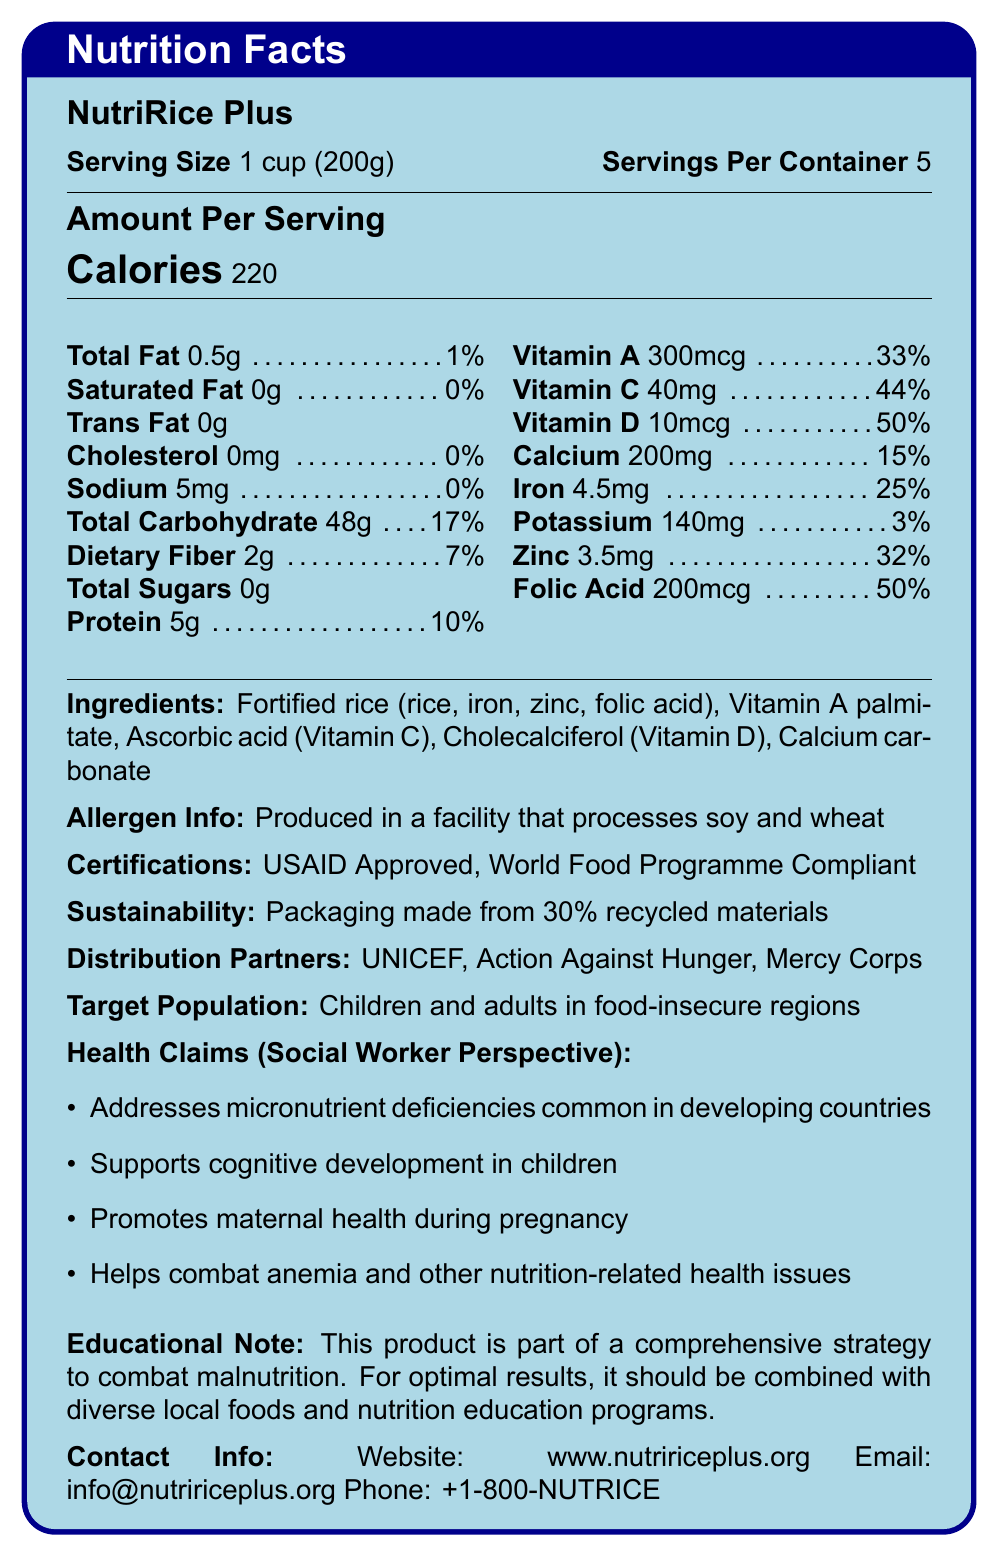what is the calorie content per serving? The document lists that each serving of NutriRice Plus contains 220 calories.
Answer: 220 calories how many servings are there in one container? The document states that there are 5 servings per container.
Answer: 5 servings what is the amount of dietary fiber per serving? The document states that each serving contains 2 grams of dietary fiber.
Answer: 2 grams which vitamin has the highest daily value percentage per serving? The document indicates that Vitamin D has a daily value percentage of 50%, which is the highest among the listed vitamins and minerals.
Answer: Vitamin D what certification does NutriRice Plus have? The document lists both “USAID Approved” and “World Food Programme Compliant” under Certifications.
Answer: USAID Approved and World Food Programme Compliant what is the total carbohydrate content per serving? The document lists the total carbohydrate content per serving as 48 grams.
Answer: 48 grams which organizations are listed as distribution partners? A. UNICEF B. Mercy Corps C. Action Against Hunger D. All of the above The document mentions UNICEF, Action Against Hunger, and Mercy Corps as distribution partners.
Answer: D what percentage of the daily value of calcium is provided in one serving? A. 10% B. 15% C. 20% D. 25% The document indicates that one serving of NutriRice Plus provides 15% of the daily value for calcium.
Answer: B does NutriRice Plus contain any trans fat? According to the document, the trans fat content in NutriRice Plus is 0g, which means it does not contain any trans fat.
Answer: No summarize the main idea of the document. The document outlines the nutritional content, certifications, and health claims associated with NutriRice Plus. It also provides information on its ingredients, allergen information, and distribution partners, highlighting its aim to combat malnutrition.
Answer: NutriRice Plus is a fortified rice product designed to address malnutrition in developing countries by providing essential vitamins and minerals. It is packaged sustainably, certified by major global organizations, and distributed by reputable partners, targeting children and adults in food-insecure regions. how much potassium is in one serving? The document states that one serving contains 140 milligrams of potassium.
Answer: 140 milligrams what are some health claims associated with NutriRice Plus from a social worker's perspective? The document lists several health claims from a social worker’s perspective, including addressing micronutrient deficiencies, supporting cognitive development, promoting maternal health, and combating anemia.
Answer: Addresses micronutrient deficiencies, supports cognitive development, promotes maternal health, helps combat anemia. does the document provide information about the environmental sustainability of the packaging? The document mentions that the packaging is made from 30% recycled materials, indicating a consideration for environmental sustainability.
Answer: Yes what are the exact amounts of Vitamin A and Vitamin C per serving? The document lists 300 mcg of Vitamin A and 40 mg of Vitamin C per serving.
Answer: Vitamin A: 300 mcg, Vitamin C: 40 mg what is the main ingredient in NutriRice Plus? The document lists fortified rice, including rice, iron, zinc, and folic acid, as the main ingredient.
Answer: Fortified rice (rice, iron, zinc, folic acid) what is the total fat content per serving and its percentage of daily value? A. 0.5g, 1% B. 0.5g, 5% C. 1g, 1% D. 1g, 5% The document indicates that the total fat content per serving is 0.5g, which corresponds to 1% of the daily value.
Answer: A who is the target population for NutriRice Plus? The document states that the target population for NutriRice Plus is children and adults in food-insecure regions.
Answer: Children and adults in food-insecure regions what is the role of folic acid in NutriRice Plus? The document mentions folic acid but does not provide specific information about its role in NutriRice Plus.
Answer: Cannot be determined 